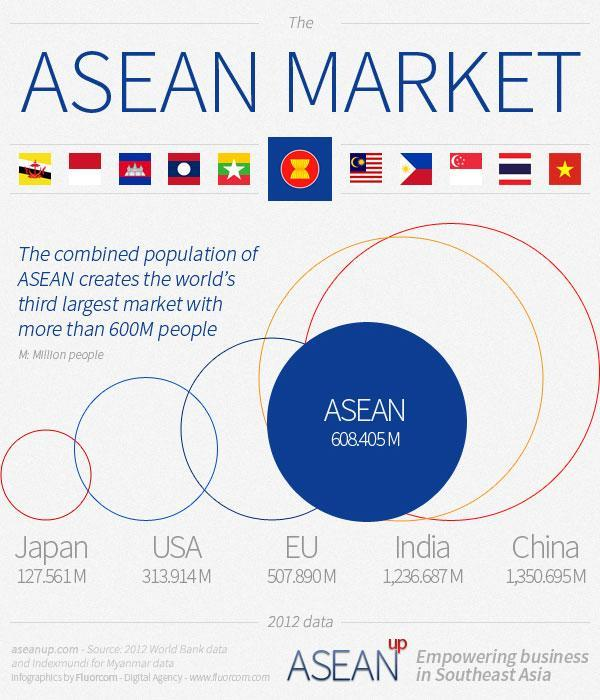How many country names are in this infographic?
Answer the question with a short phrase. 5 How many country flags are in this infographic? 11 